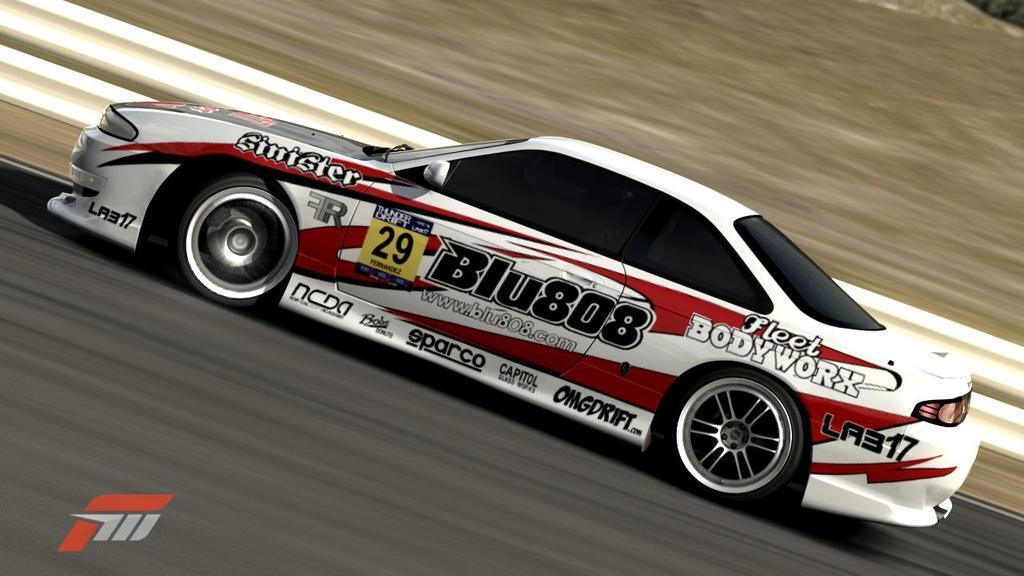Describe this image in one or two sentences. In this picture, we see a car in white and red color is moving on the road. At the bottom, we see the road. Beside the car, we see a road railing. In the background, we see the grass. This picture is blurred in the background. 